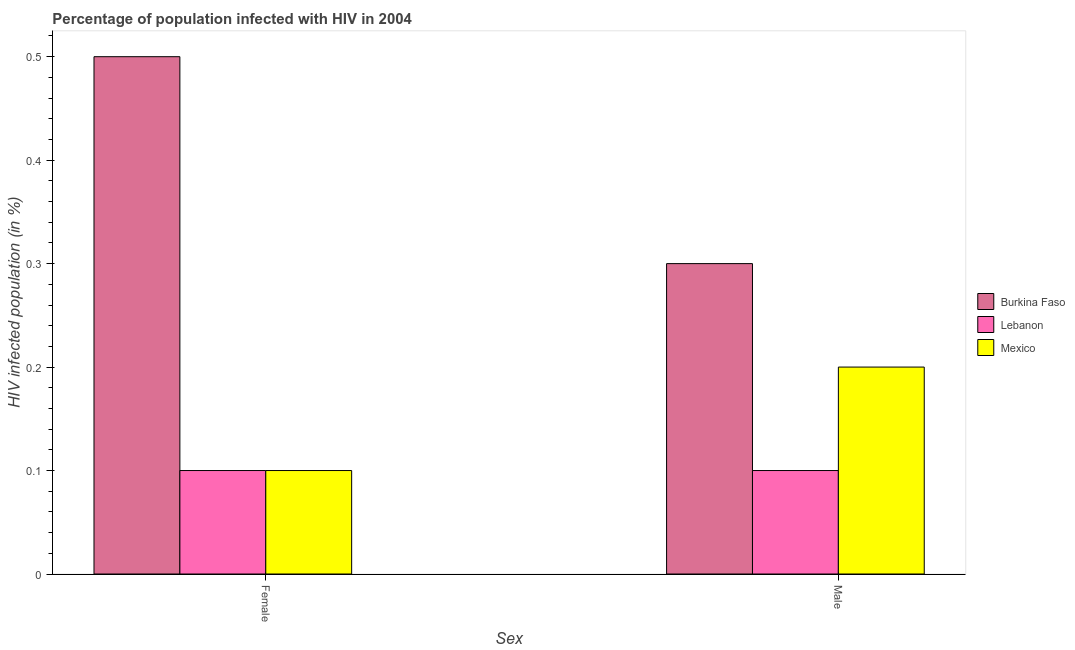Are the number of bars per tick equal to the number of legend labels?
Your answer should be compact. Yes. Are the number of bars on each tick of the X-axis equal?
Your answer should be very brief. Yes. How many bars are there on the 1st tick from the right?
Offer a terse response. 3. What is the label of the 1st group of bars from the left?
Offer a terse response. Female. What is the percentage of females who are infected with hiv in Burkina Faso?
Your answer should be compact. 0.5. Across all countries, what is the maximum percentage of males who are infected with hiv?
Provide a succinct answer. 0.3. In which country was the percentage of males who are infected with hiv maximum?
Ensure brevity in your answer.  Burkina Faso. In which country was the percentage of females who are infected with hiv minimum?
Offer a terse response. Lebanon. What is the total percentage of females who are infected with hiv in the graph?
Your answer should be compact. 0.7. What is the average percentage of males who are infected with hiv per country?
Provide a succinct answer. 0.2. What is the difference between the percentage of females who are infected with hiv and percentage of males who are infected with hiv in Burkina Faso?
Keep it short and to the point. 0.2. In how many countries, is the percentage of males who are infected with hiv greater than 0.26 %?
Ensure brevity in your answer.  1. What is the ratio of the percentage of females who are infected with hiv in Burkina Faso to that in Mexico?
Keep it short and to the point. 5. Is the percentage of males who are infected with hiv in Mexico less than that in Lebanon?
Make the answer very short. No. In how many countries, is the percentage of males who are infected with hiv greater than the average percentage of males who are infected with hiv taken over all countries?
Provide a succinct answer. 1. What does the 1st bar from the left in Female represents?
Offer a very short reply. Burkina Faso. What does the 3rd bar from the right in Male represents?
Provide a succinct answer. Burkina Faso. Are all the bars in the graph horizontal?
Make the answer very short. No. How many countries are there in the graph?
Your response must be concise. 3. Where does the legend appear in the graph?
Your response must be concise. Center right. What is the title of the graph?
Keep it short and to the point. Percentage of population infected with HIV in 2004. Does "United States" appear as one of the legend labels in the graph?
Your answer should be compact. No. What is the label or title of the X-axis?
Keep it short and to the point. Sex. What is the label or title of the Y-axis?
Provide a short and direct response. HIV infected population (in %). What is the HIV infected population (in %) in Lebanon in Female?
Make the answer very short. 0.1. What is the HIV infected population (in %) of Mexico in Female?
Keep it short and to the point. 0.1. What is the HIV infected population (in %) in Lebanon in Male?
Provide a short and direct response. 0.1. What is the HIV infected population (in %) of Mexico in Male?
Offer a very short reply. 0.2. Across all Sex, what is the maximum HIV infected population (in %) of Burkina Faso?
Keep it short and to the point. 0.5. Across all Sex, what is the minimum HIV infected population (in %) of Burkina Faso?
Provide a short and direct response. 0.3. Across all Sex, what is the minimum HIV infected population (in %) of Lebanon?
Ensure brevity in your answer.  0.1. Across all Sex, what is the minimum HIV infected population (in %) of Mexico?
Your answer should be compact. 0.1. What is the total HIV infected population (in %) of Lebanon in the graph?
Ensure brevity in your answer.  0.2. What is the total HIV infected population (in %) of Mexico in the graph?
Offer a very short reply. 0.3. What is the difference between the HIV infected population (in %) in Burkina Faso in Female and that in Male?
Your answer should be very brief. 0.2. What is the difference between the HIV infected population (in %) of Lebanon in Female and that in Male?
Ensure brevity in your answer.  0. What is the difference between the HIV infected population (in %) of Burkina Faso in Female and the HIV infected population (in %) of Lebanon in Male?
Your response must be concise. 0.4. What is the difference between the HIV infected population (in %) of Burkina Faso in Female and the HIV infected population (in %) of Mexico in Male?
Ensure brevity in your answer.  0.3. What is the difference between the HIV infected population (in %) of Lebanon in Female and the HIV infected population (in %) of Mexico in Male?
Offer a very short reply. -0.1. What is the average HIV infected population (in %) of Burkina Faso per Sex?
Provide a short and direct response. 0.4. What is the average HIV infected population (in %) in Mexico per Sex?
Ensure brevity in your answer.  0.15. What is the difference between the HIV infected population (in %) of Burkina Faso and HIV infected population (in %) of Lebanon in Female?
Keep it short and to the point. 0.4. What is the difference between the HIV infected population (in %) in Burkina Faso and HIV infected population (in %) in Mexico in Female?
Your answer should be compact. 0.4. What is the difference between the HIV infected population (in %) of Burkina Faso and HIV infected population (in %) of Lebanon in Male?
Provide a succinct answer. 0.2. What is the ratio of the HIV infected population (in %) in Burkina Faso in Female to that in Male?
Your answer should be very brief. 1.67. What is the ratio of the HIV infected population (in %) in Lebanon in Female to that in Male?
Provide a succinct answer. 1. What is the difference between the highest and the second highest HIV infected population (in %) of Burkina Faso?
Give a very brief answer. 0.2. What is the difference between the highest and the second highest HIV infected population (in %) in Lebanon?
Provide a short and direct response. 0. What is the difference between the highest and the second highest HIV infected population (in %) in Mexico?
Make the answer very short. 0.1. What is the difference between the highest and the lowest HIV infected population (in %) of Lebanon?
Your response must be concise. 0. What is the difference between the highest and the lowest HIV infected population (in %) in Mexico?
Your answer should be very brief. 0.1. 